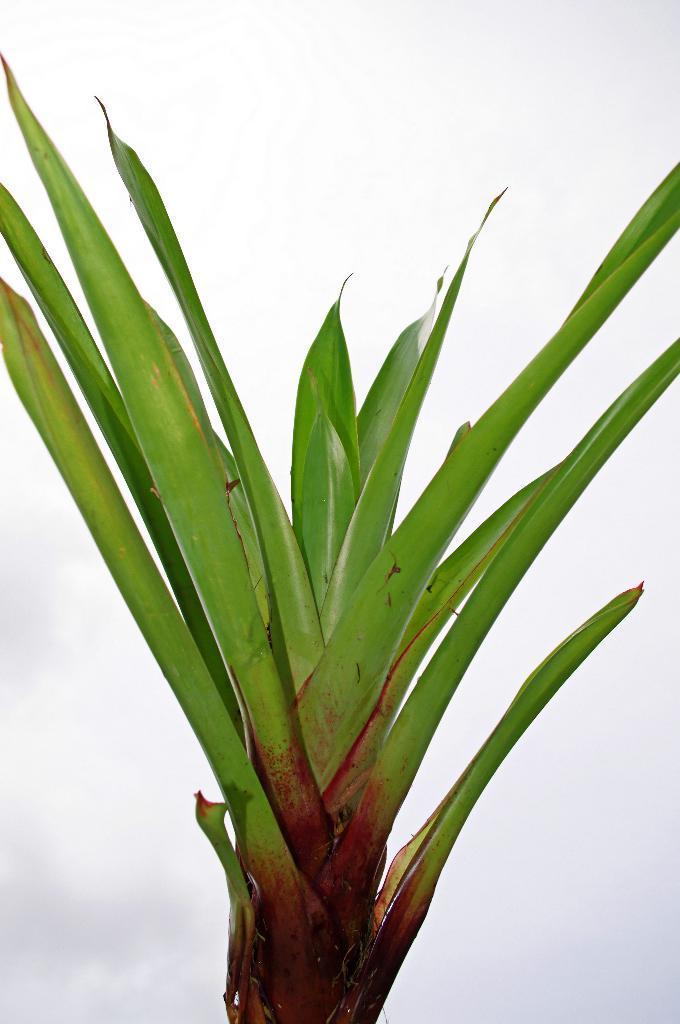Can you describe this image briefly? In this picture we can see a plant and in the background we can see the sky with clouds. 